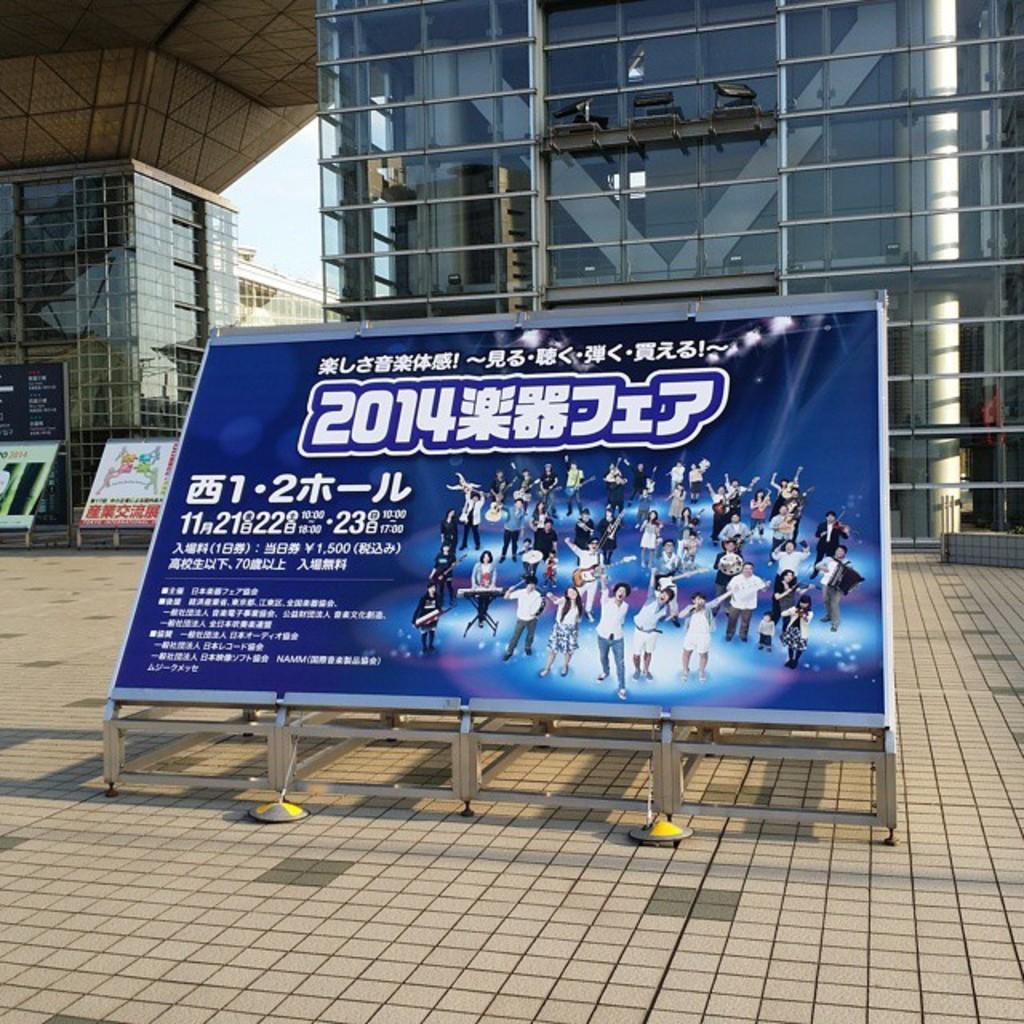Provide a one-sentence caption for the provided image. A large billboard for a show in 2014 written in an Asian language sits in front of a glass building. 